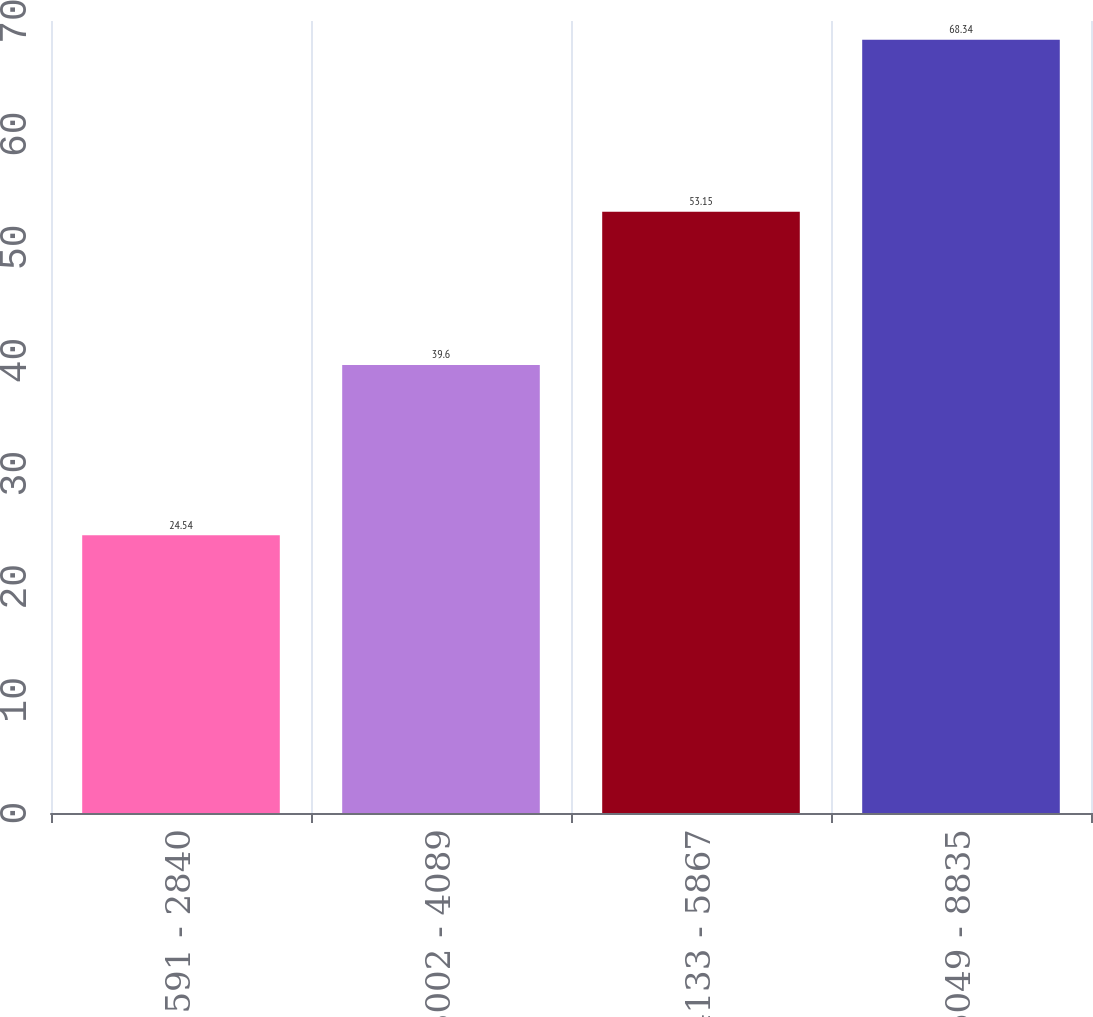Convert chart. <chart><loc_0><loc_0><loc_500><loc_500><bar_chart><fcel>591 - 2840<fcel>3002 - 4089<fcel>4133 - 5867<fcel>6049 - 8835<nl><fcel>24.54<fcel>39.6<fcel>53.15<fcel>68.34<nl></chart> 